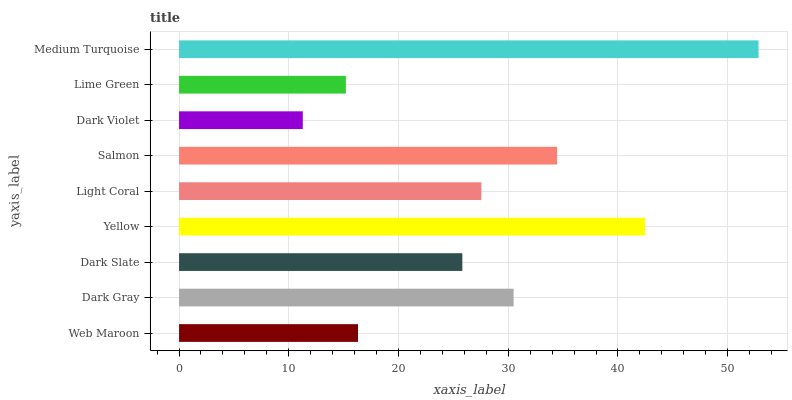Is Dark Violet the minimum?
Answer yes or no. Yes. Is Medium Turquoise the maximum?
Answer yes or no. Yes. Is Dark Gray the minimum?
Answer yes or no. No. Is Dark Gray the maximum?
Answer yes or no. No. Is Dark Gray greater than Web Maroon?
Answer yes or no. Yes. Is Web Maroon less than Dark Gray?
Answer yes or no. Yes. Is Web Maroon greater than Dark Gray?
Answer yes or no. No. Is Dark Gray less than Web Maroon?
Answer yes or no. No. Is Light Coral the high median?
Answer yes or no. Yes. Is Light Coral the low median?
Answer yes or no. Yes. Is Salmon the high median?
Answer yes or no. No. Is Lime Green the low median?
Answer yes or no. No. 